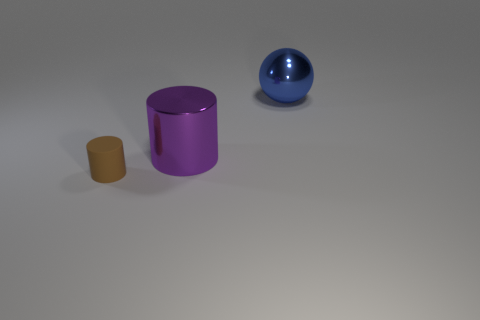Add 2 matte things. How many objects exist? 5 Subtract all brown cylinders. Subtract all blue spheres. How many cylinders are left? 1 Subtract all cylinders. How many objects are left? 1 Subtract all brown cubes. How many purple cylinders are left? 1 Subtract all tiny brown matte things. Subtract all metal things. How many objects are left? 0 Add 1 brown things. How many brown things are left? 2 Add 3 tiny brown matte cylinders. How many tiny brown matte cylinders exist? 4 Subtract 0 brown cubes. How many objects are left? 3 